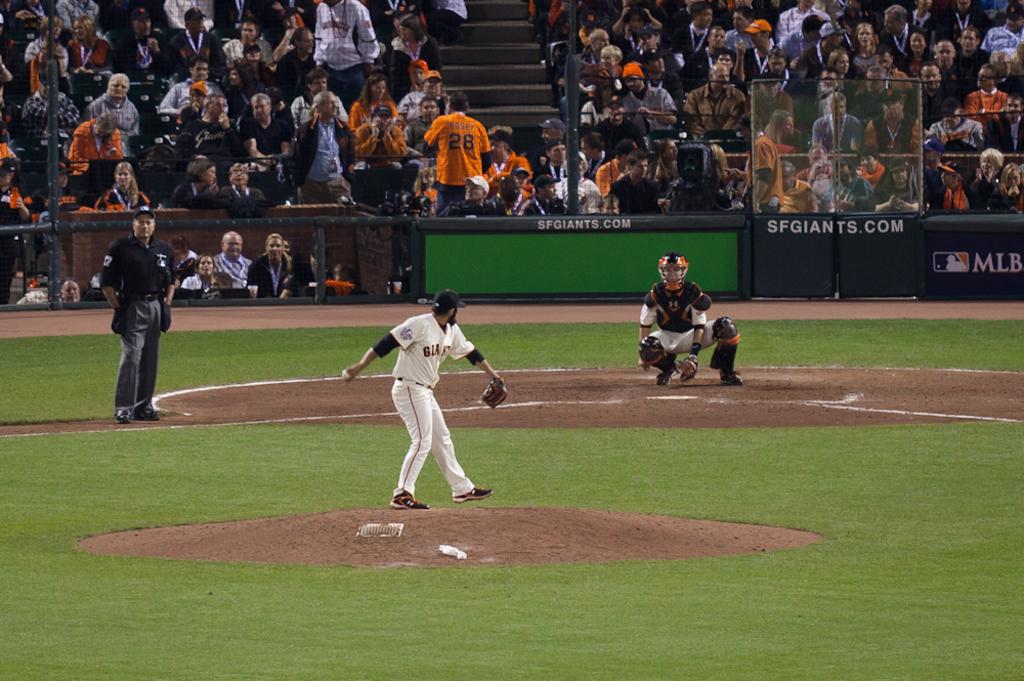<image>
Provide a brief description of the given image. While the Giants pitcher is about to throw a ball to the catcher a fan in the stands wearing a Posey jersey is facing the crowd and not the game. 